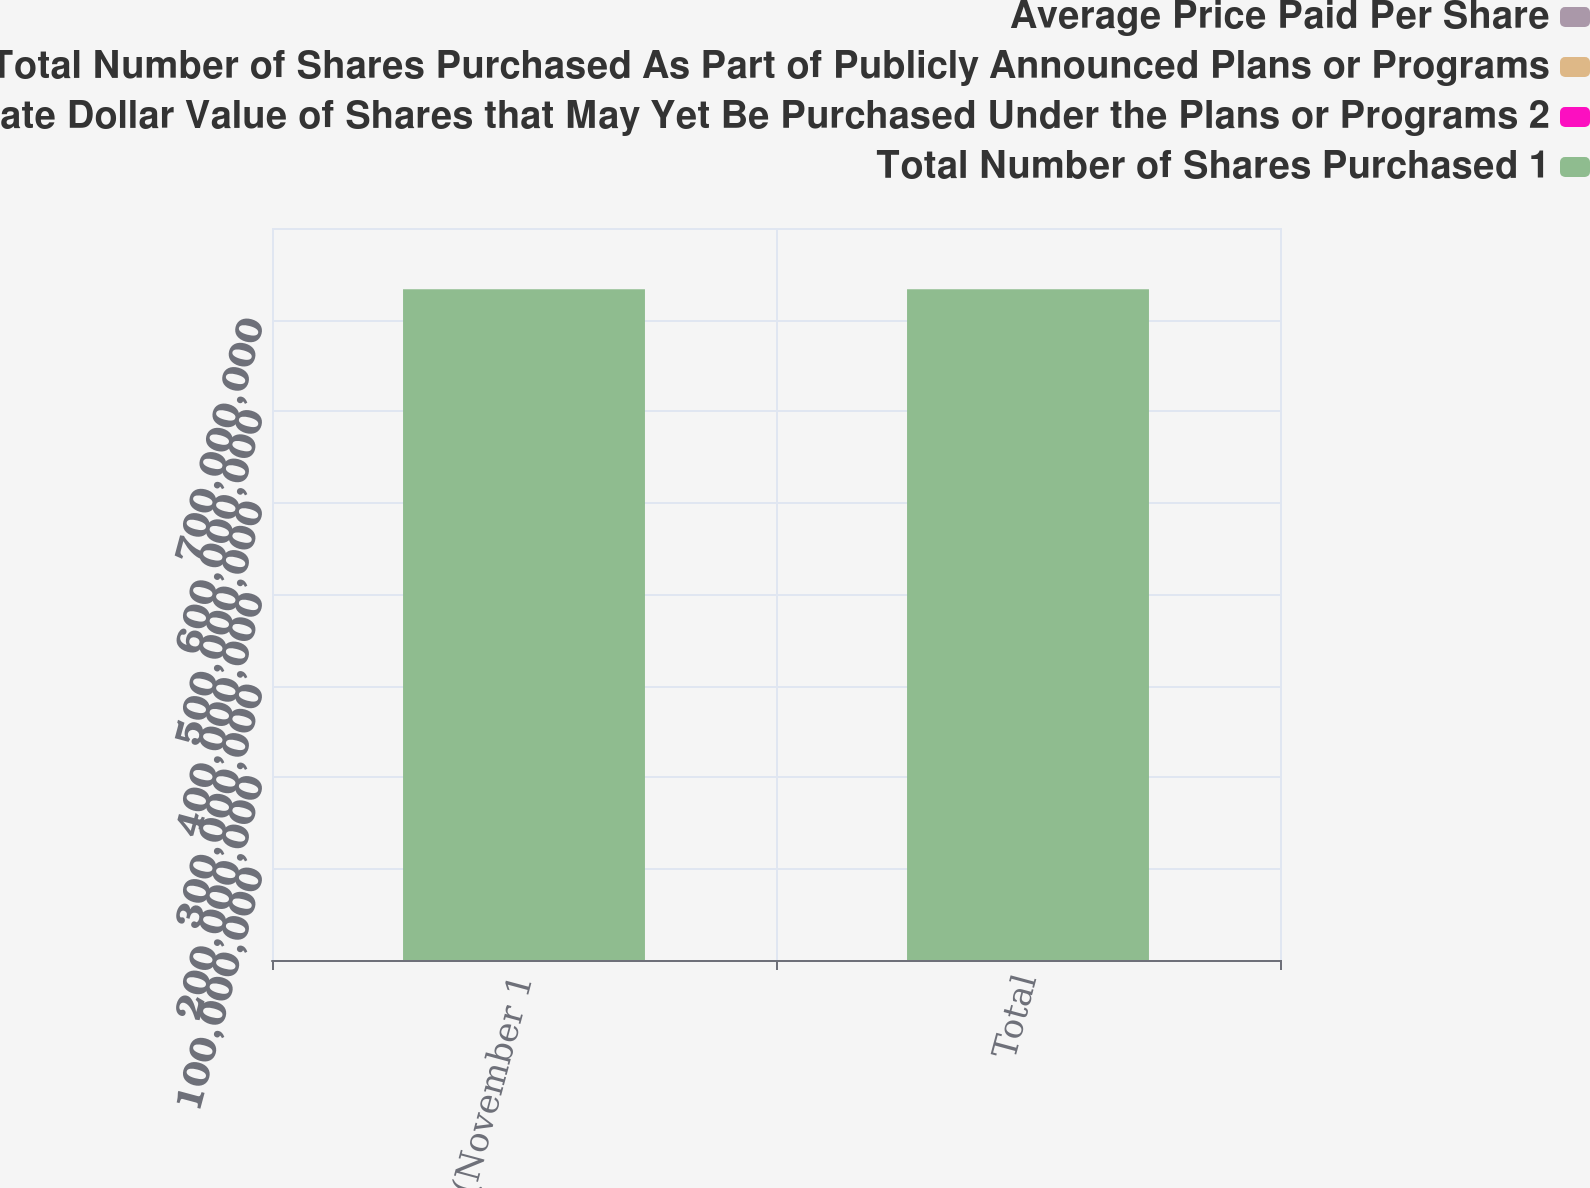Convert chart. <chart><loc_0><loc_0><loc_500><loc_500><stacked_bar_chart><ecel><fcel>Month 2 (November 1<fcel>Total<nl><fcel>Average Price Paid Per Share<fcel>400<fcel>894<nl><fcel>Total Number of Shares Purchased As Part of Publicly Announced Plans or Programs<fcel>124<fcel>122.41<nl><fcel>Approximate Dollar Value of Shares that May Yet Be Purchased Under the Plans or Programs 2<fcel>400<fcel>400<nl><fcel>Total Number of Shares Purchased 1<fcel>7.33073e+08<fcel>7.33073e+08<nl></chart> 